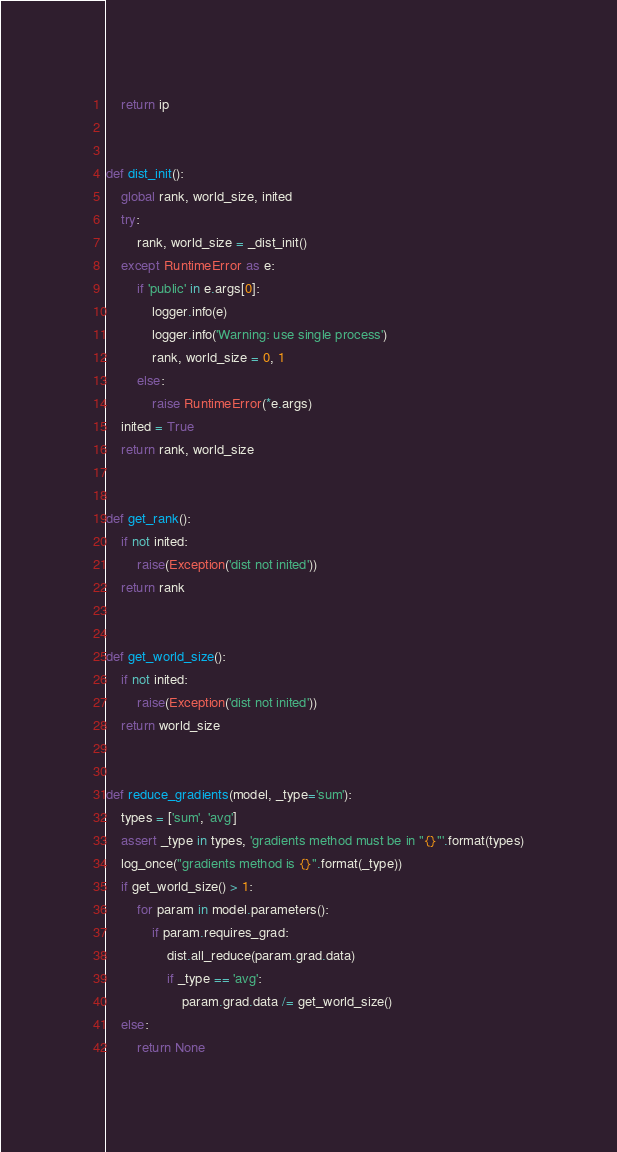<code> <loc_0><loc_0><loc_500><loc_500><_Python_>    return ip


def dist_init():
    global rank, world_size, inited
    try:
        rank, world_size = _dist_init()
    except RuntimeError as e:
        if 'public' in e.args[0]:
            logger.info(e)
            logger.info('Warning: use single process')
            rank, world_size = 0, 1
        else:
            raise RuntimeError(*e.args)
    inited = True
    return rank, world_size


def get_rank():
    if not inited:
        raise(Exception('dist not inited'))
    return rank


def get_world_size():
    if not inited:
        raise(Exception('dist not inited'))
    return world_size


def reduce_gradients(model, _type='sum'):
    types = ['sum', 'avg']
    assert _type in types, 'gradients method must be in "{}"'.format(types)
    log_once("gradients method is {}".format(_type))
    if get_world_size() > 1:
        for param in model.parameters():
            if param.requires_grad:
                dist.all_reduce(param.grad.data)
                if _type == 'avg':
                    param.grad.data /= get_world_size()
    else:
        return None
</code> 